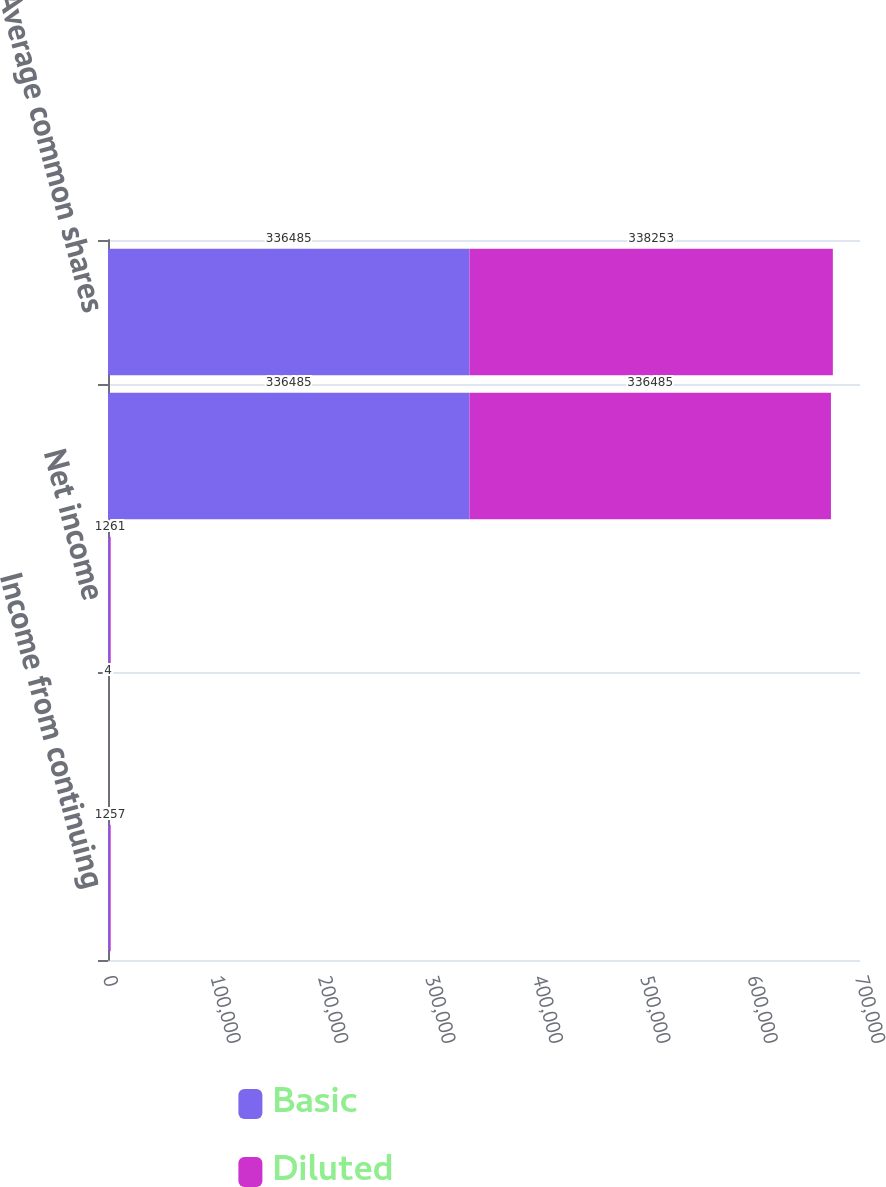Convert chart. <chart><loc_0><loc_0><loc_500><loc_500><stacked_bar_chart><ecel><fcel>Income from continuing<fcel>Income (loss) from<fcel>Net income<fcel>Average number of common<fcel>Average common shares<nl><fcel>Basic<fcel>1257<fcel>4<fcel>1261<fcel>336485<fcel>336485<nl><fcel>Diluted<fcel>1257<fcel>4<fcel>1261<fcel>336485<fcel>338253<nl></chart> 